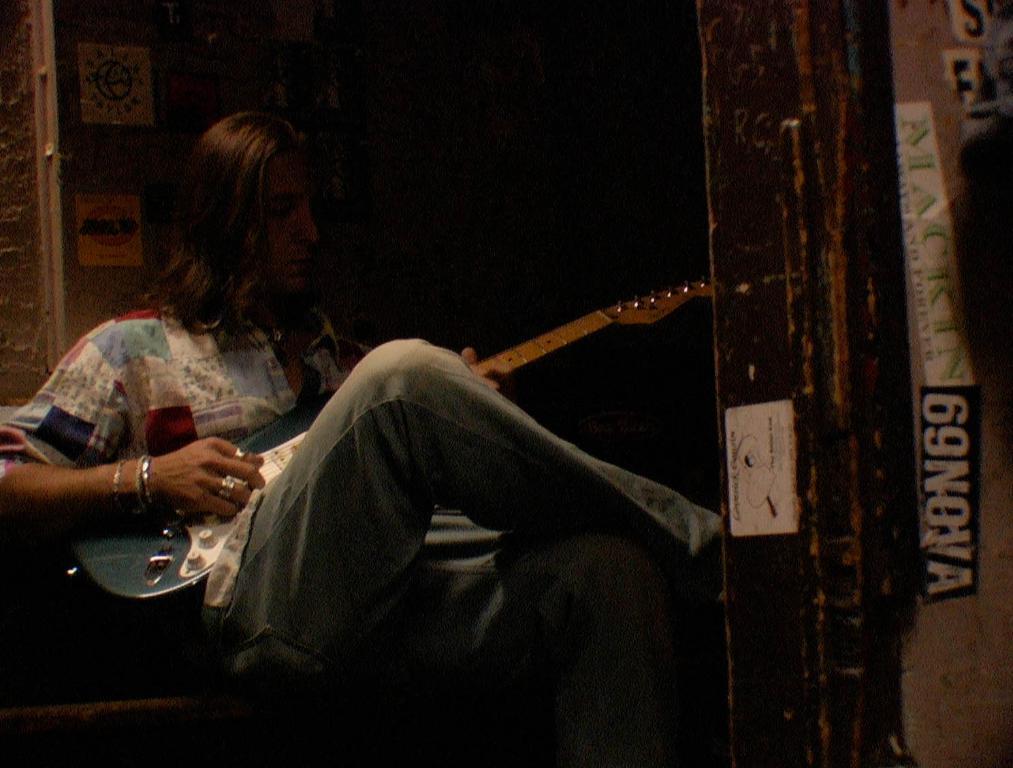What number is next to the word "nova"?
Offer a very short reply. 69. 